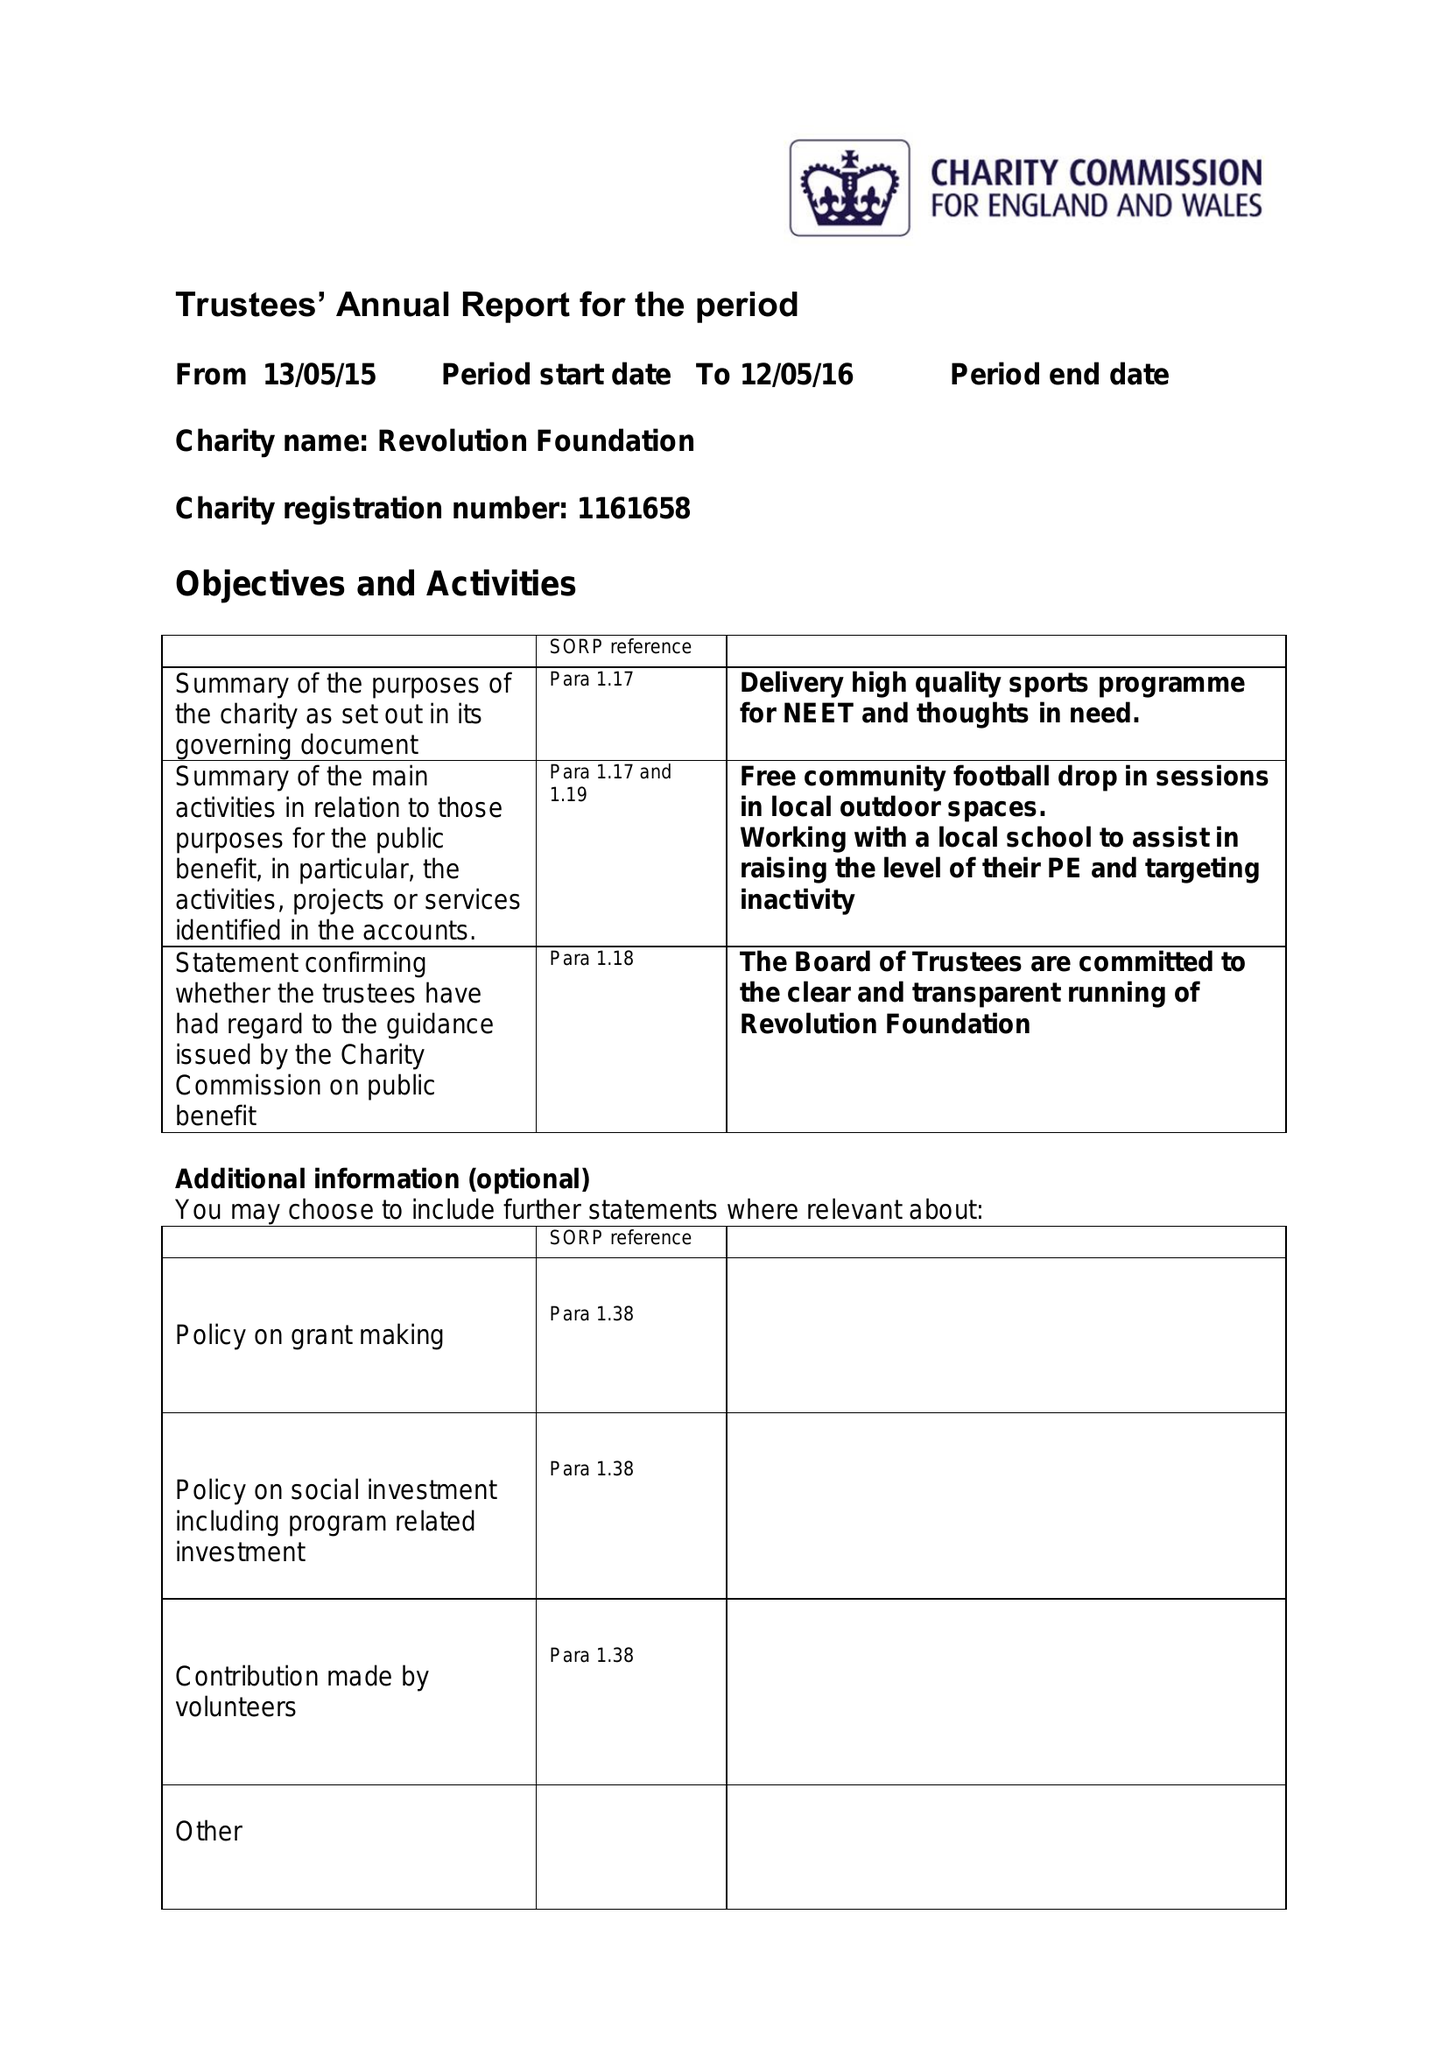What is the value for the charity_name?
Answer the question using a single word or phrase. Revolution Foundation 